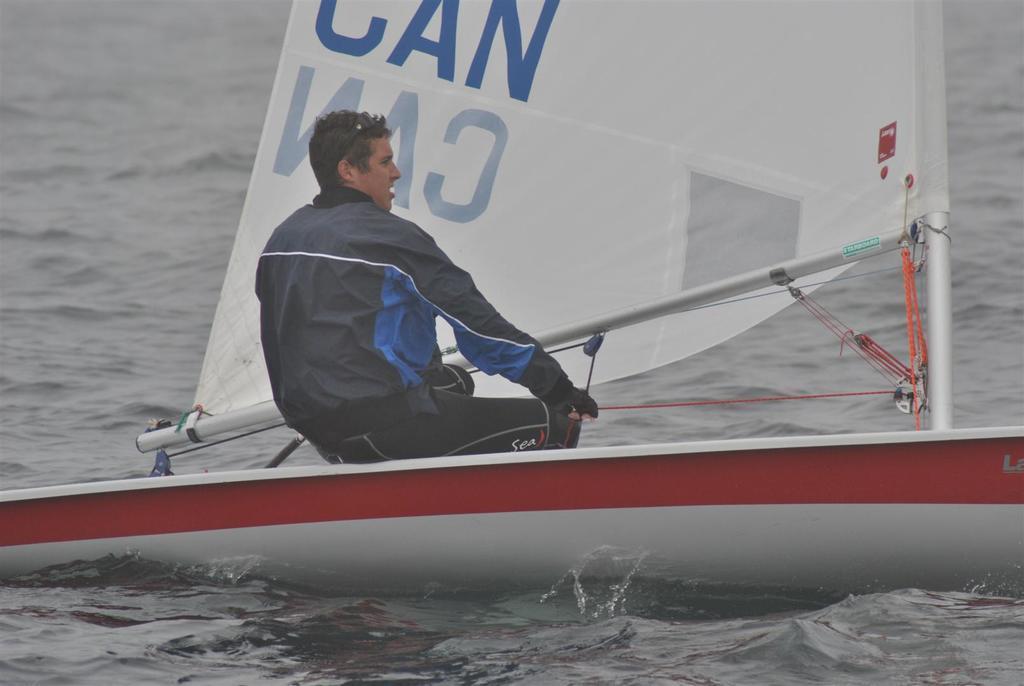How would you summarize this image in a sentence or two? In this image we can see a person wearing black dress is sitting in the sailboat which is floating on the water. Here we can see a white cloth on which we can see some edited text which is in blue color. 